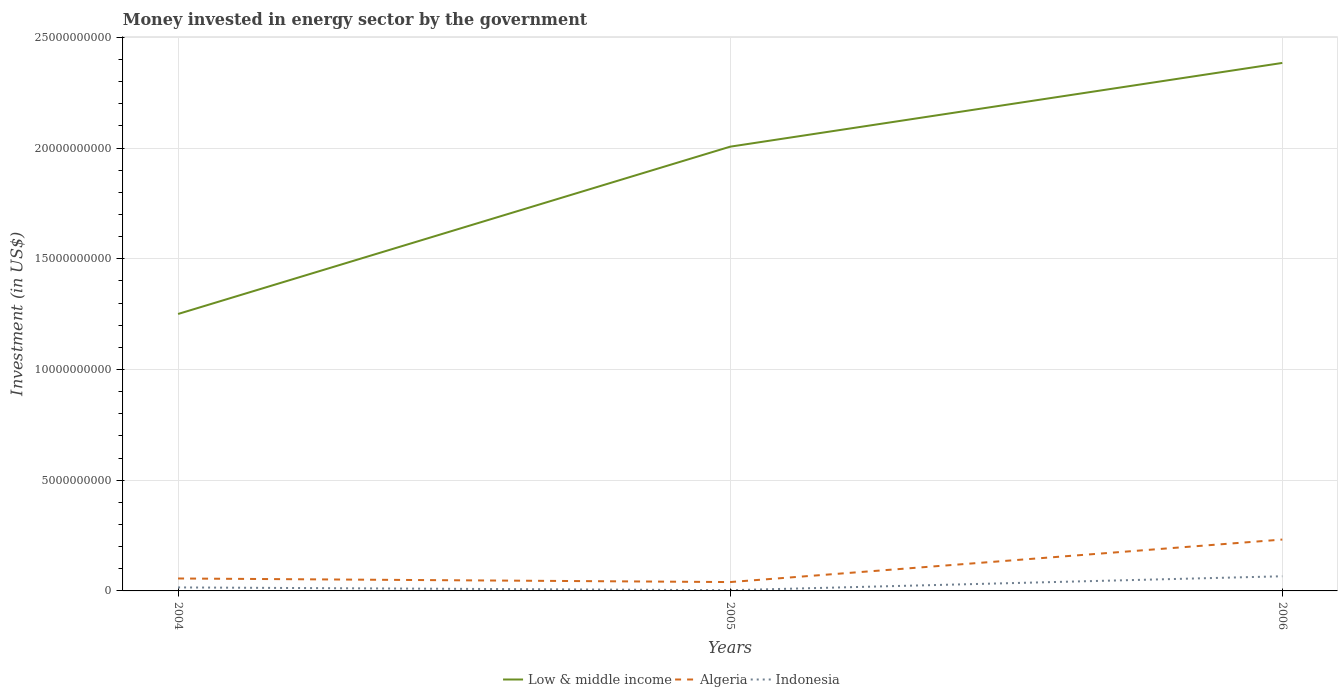Across all years, what is the maximum money spent in energy sector in Indonesia?
Keep it short and to the point. 3.20e+07. In which year was the money spent in energy sector in Low & middle income maximum?
Give a very brief answer. 2004. What is the total money spent in energy sector in Indonesia in the graph?
Provide a succinct answer. 1.26e+08. What is the difference between the highest and the second highest money spent in energy sector in Algeria?
Provide a short and direct response. 1.92e+09. Is the money spent in energy sector in Low & middle income strictly greater than the money spent in energy sector in Algeria over the years?
Your answer should be very brief. No. How many lines are there?
Give a very brief answer. 3. Does the graph contain grids?
Your answer should be very brief. Yes. Where does the legend appear in the graph?
Your answer should be very brief. Bottom center. How are the legend labels stacked?
Offer a terse response. Horizontal. What is the title of the graph?
Ensure brevity in your answer.  Money invested in energy sector by the government. What is the label or title of the X-axis?
Make the answer very short. Years. What is the label or title of the Y-axis?
Ensure brevity in your answer.  Investment (in US$). What is the Investment (in US$) of Low & middle income in 2004?
Your response must be concise. 1.25e+1. What is the Investment (in US$) of Algeria in 2004?
Your response must be concise. 5.62e+08. What is the Investment (in US$) of Indonesia in 2004?
Ensure brevity in your answer.  1.58e+08. What is the Investment (in US$) of Low & middle income in 2005?
Provide a succinct answer. 2.01e+1. What is the Investment (in US$) in Algeria in 2005?
Offer a very short reply. 4.00e+08. What is the Investment (in US$) of Indonesia in 2005?
Your answer should be compact. 3.20e+07. What is the Investment (in US$) in Low & middle income in 2006?
Your response must be concise. 2.38e+1. What is the Investment (in US$) of Algeria in 2006?
Your answer should be very brief. 2.32e+09. What is the Investment (in US$) of Indonesia in 2006?
Provide a succinct answer. 6.62e+08. Across all years, what is the maximum Investment (in US$) of Low & middle income?
Make the answer very short. 2.38e+1. Across all years, what is the maximum Investment (in US$) of Algeria?
Your answer should be very brief. 2.32e+09. Across all years, what is the maximum Investment (in US$) of Indonesia?
Provide a succinct answer. 6.62e+08. Across all years, what is the minimum Investment (in US$) of Low & middle income?
Provide a short and direct response. 1.25e+1. Across all years, what is the minimum Investment (in US$) in Algeria?
Provide a succinct answer. 4.00e+08. Across all years, what is the minimum Investment (in US$) in Indonesia?
Give a very brief answer. 3.20e+07. What is the total Investment (in US$) of Low & middle income in the graph?
Ensure brevity in your answer.  5.64e+1. What is the total Investment (in US$) of Algeria in the graph?
Your answer should be very brief. 3.28e+09. What is the total Investment (in US$) of Indonesia in the graph?
Keep it short and to the point. 8.52e+08. What is the difference between the Investment (in US$) of Low & middle income in 2004 and that in 2005?
Offer a terse response. -7.56e+09. What is the difference between the Investment (in US$) of Algeria in 2004 and that in 2005?
Keep it short and to the point. 1.62e+08. What is the difference between the Investment (in US$) in Indonesia in 2004 and that in 2005?
Provide a short and direct response. 1.26e+08. What is the difference between the Investment (in US$) in Low & middle income in 2004 and that in 2006?
Ensure brevity in your answer.  -1.13e+1. What is the difference between the Investment (in US$) of Algeria in 2004 and that in 2006?
Keep it short and to the point. -1.76e+09. What is the difference between the Investment (in US$) of Indonesia in 2004 and that in 2006?
Provide a short and direct response. -5.04e+08. What is the difference between the Investment (in US$) of Low & middle income in 2005 and that in 2006?
Provide a succinct answer. -3.78e+09. What is the difference between the Investment (in US$) in Algeria in 2005 and that in 2006?
Your answer should be very brief. -1.92e+09. What is the difference between the Investment (in US$) in Indonesia in 2005 and that in 2006?
Your response must be concise. -6.30e+08. What is the difference between the Investment (in US$) of Low & middle income in 2004 and the Investment (in US$) of Algeria in 2005?
Your answer should be very brief. 1.21e+1. What is the difference between the Investment (in US$) in Low & middle income in 2004 and the Investment (in US$) in Indonesia in 2005?
Provide a succinct answer. 1.25e+1. What is the difference between the Investment (in US$) in Algeria in 2004 and the Investment (in US$) in Indonesia in 2005?
Provide a succinct answer. 5.30e+08. What is the difference between the Investment (in US$) in Low & middle income in 2004 and the Investment (in US$) in Algeria in 2006?
Make the answer very short. 1.02e+1. What is the difference between the Investment (in US$) in Low & middle income in 2004 and the Investment (in US$) in Indonesia in 2006?
Offer a terse response. 1.18e+1. What is the difference between the Investment (in US$) of Algeria in 2004 and the Investment (in US$) of Indonesia in 2006?
Give a very brief answer. -1.00e+08. What is the difference between the Investment (in US$) in Low & middle income in 2005 and the Investment (in US$) in Algeria in 2006?
Your response must be concise. 1.77e+1. What is the difference between the Investment (in US$) of Low & middle income in 2005 and the Investment (in US$) of Indonesia in 2006?
Offer a very short reply. 1.94e+1. What is the difference between the Investment (in US$) of Algeria in 2005 and the Investment (in US$) of Indonesia in 2006?
Your answer should be very brief. -2.62e+08. What is the average Investment (in US$) in Low & middle income per year?
Keep it short and to the point. 1.88e+1. What is the average Investment (in US$) of Algeria per year?
Make the answer very short. 1.09e+09. What is the average Investment (in US$) of Indonesia per year?
Give a very brief answer. 2.84e+08. In the year 2004, what is the difference between the Investment (in US$) in Low & middle income and Investment (in US$) in Algeria?
Make the answer very short. 1.19e+1. In the year 2004, what is the difference between the Investment (in US$) of Low & middle income and Investment (in US$) of Indonesia?
Your answer should be compact. 1.23e+1. In the year 2004, what is the difference between the Investment (in US$) in Algeria and Investment (in US$) in Indonesia?
Your answer should be compact. 4.04e+08. In the year 2005, what is the difference between the Investment (in US$) of Low & middle income and Investment (in US$) of Algeria?
Your answer should be compact. 1.97e+1. In the year 2005, what is the difference between the Investment (in US$) of Low & middle income and Investment (in US$) of Indonesia?
Provide a short and direct response. 2.00e+1. In the year 2005, what is the difference between the Investment (in US$) in Algeria and Investment (in US$) in Indonesia?
Provide a succinct answer. 3.68e+08. In the year 2006, what is the difference between the Investment (in US$) in Low & middle income and Investment (in US$) in Algeria?
Your answer should be very brief. 2.15e+1. In the year 2006, what is the difference between the Investment (in US$) of Low & middle income and Investment (in US$) of Indonesia?
Ensure brevity in your answer.  2.32e+1. In the year 2006, what is the difference between the Investment (in US$) of Algeria and Investment (in US$) of Indonesia?
Make the answer very short. 1.66e+09. What is the ratio of the Investment (in US$) of Low & middle income in 2004 to that in 2005?
Provide a short and direct response. 0.62. What is the ratio of the Investment (in US$) in Algeria in 2004 to that in 2005?
Give a very brief answer. 1.41. What is the ratio of the Investment (in US$) in Indonesia in 2004 to that in 2005?
Give a very brief answer. 4.94. What is the ratio of the Investment (in US$) of Low & middle income in 2004 to that in 2006?
Make the answer very short. 0.52. What is the ratio of the Investment (in US$) in Algeria in 2004 to that in 2006?
Ensure brevity in your answer.  0.24. What is the ratio of the Investment (in US$) of Indonesia in 2004 to that in 2006?
Your answer should be compact. 0.24. What is the ratio of the Investment (in US$) in Low & middle income in 2005 to that in 2006?
Provide a short and direct response. 0.84. What is the ratio of the Investment (in US$) in Algeria in 2005 to that in 2006?
Offer a very short reply. 0.17. What is the ratio of the Investment (in US$) of Indonesia in 2005 to that in 2006?
Your response must be concise. 0.05. What is the difference between the highest and the second highest Investment (in US$) in Low & middle income?
Offer a very short reply. 3.78e+09. What is the difference between the highest and the second highest Investment (in US$) of Algeria?
Provide a succinct answer. 1.76e+09. What is the difference between the highest and the second highest Investment (in US$) in Indonesia?
Ensure brevity in your answer.  5.04e+08. What is the difference between the highest and the lowest Investment (in US$) in Low & middle income?
Ensure brevity in your answer.  1.13e+1. What is the difference between the highest and the lowest Investment (in US$) of Algeria?
Your answer should be compact. 1.92e+09. What is the difference between the highest and the lowest Investment (in US$) of Indonesia?
Your answer should be very brief. 6.30e+08. 